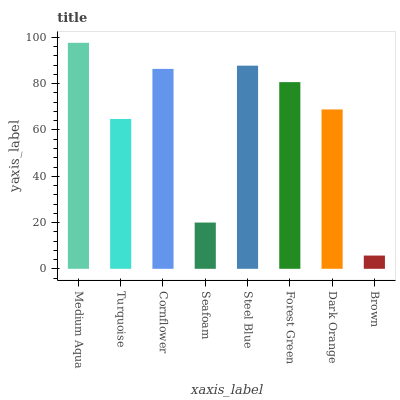Is Turquoise the minimum?
Answer yes or no. No. Is Turquoise the maximum?
Answer yes or no. No. Is Medium Aqua greater than Turquoise?
Answer yes or no. Yes. Is Turquoise less than Medium Aqua?
Answer yes or no. Yes. Is Turquoise greater than Medium Aqua?
Answer yes or no. No. Is Medium Aqua less than Turquoise?
Answer yes or no. No. Is Forest Green the high median?
Answer yes or no. Yes. Is Dark Orange the low median?
Answer yes or no. Yes. Is Cornflower the high median?
Answer yes or no. No. Is Medium Aqua the low median?
Answer yes or no. No. 